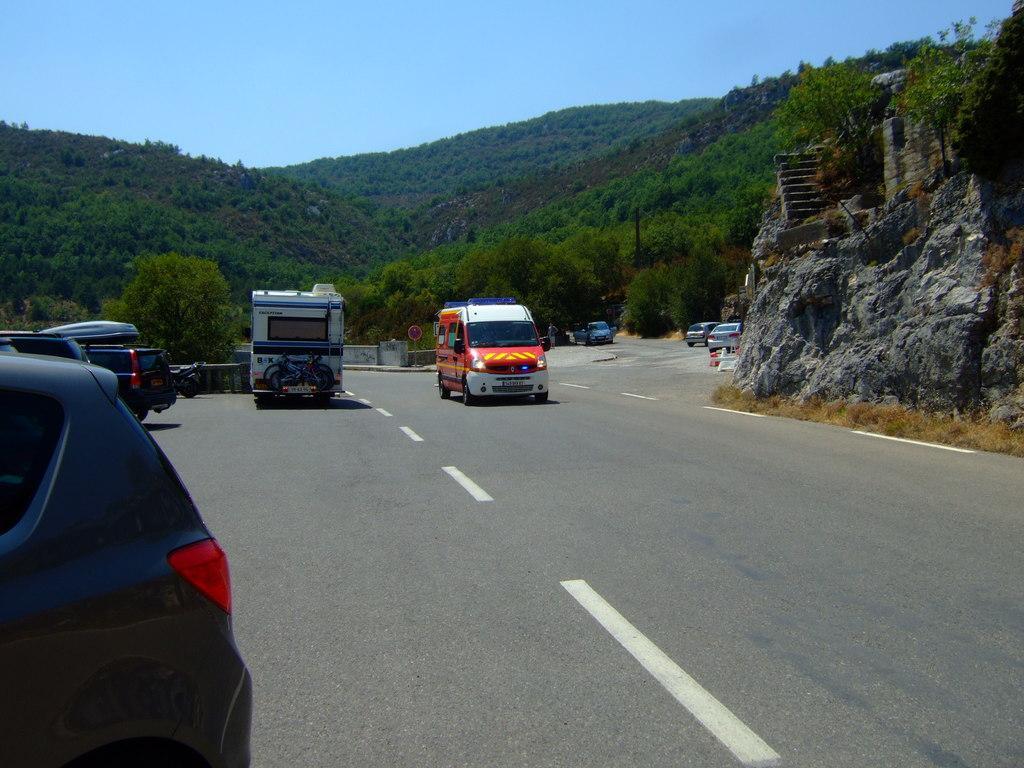Please provide a concise description of this image. This picture is clicked outside, we can see the group of vehicles seems to be running on the road. In the background there is a sky, trees, hills, stairs and rocks and some other items. 